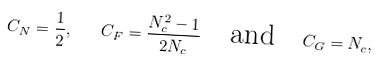Convert formula to latex. <formula><loc_0><loc_0><loc_500><loc_500>C _ { N } = \frac { 1 } { 2 } , \quad C _ { F } = \frac { N _ { c } ^ { 2 } - 1 } { 2 N _ { c } } \quad \text {and} \quad C _ { G } = N _ { c } ,</formula> 